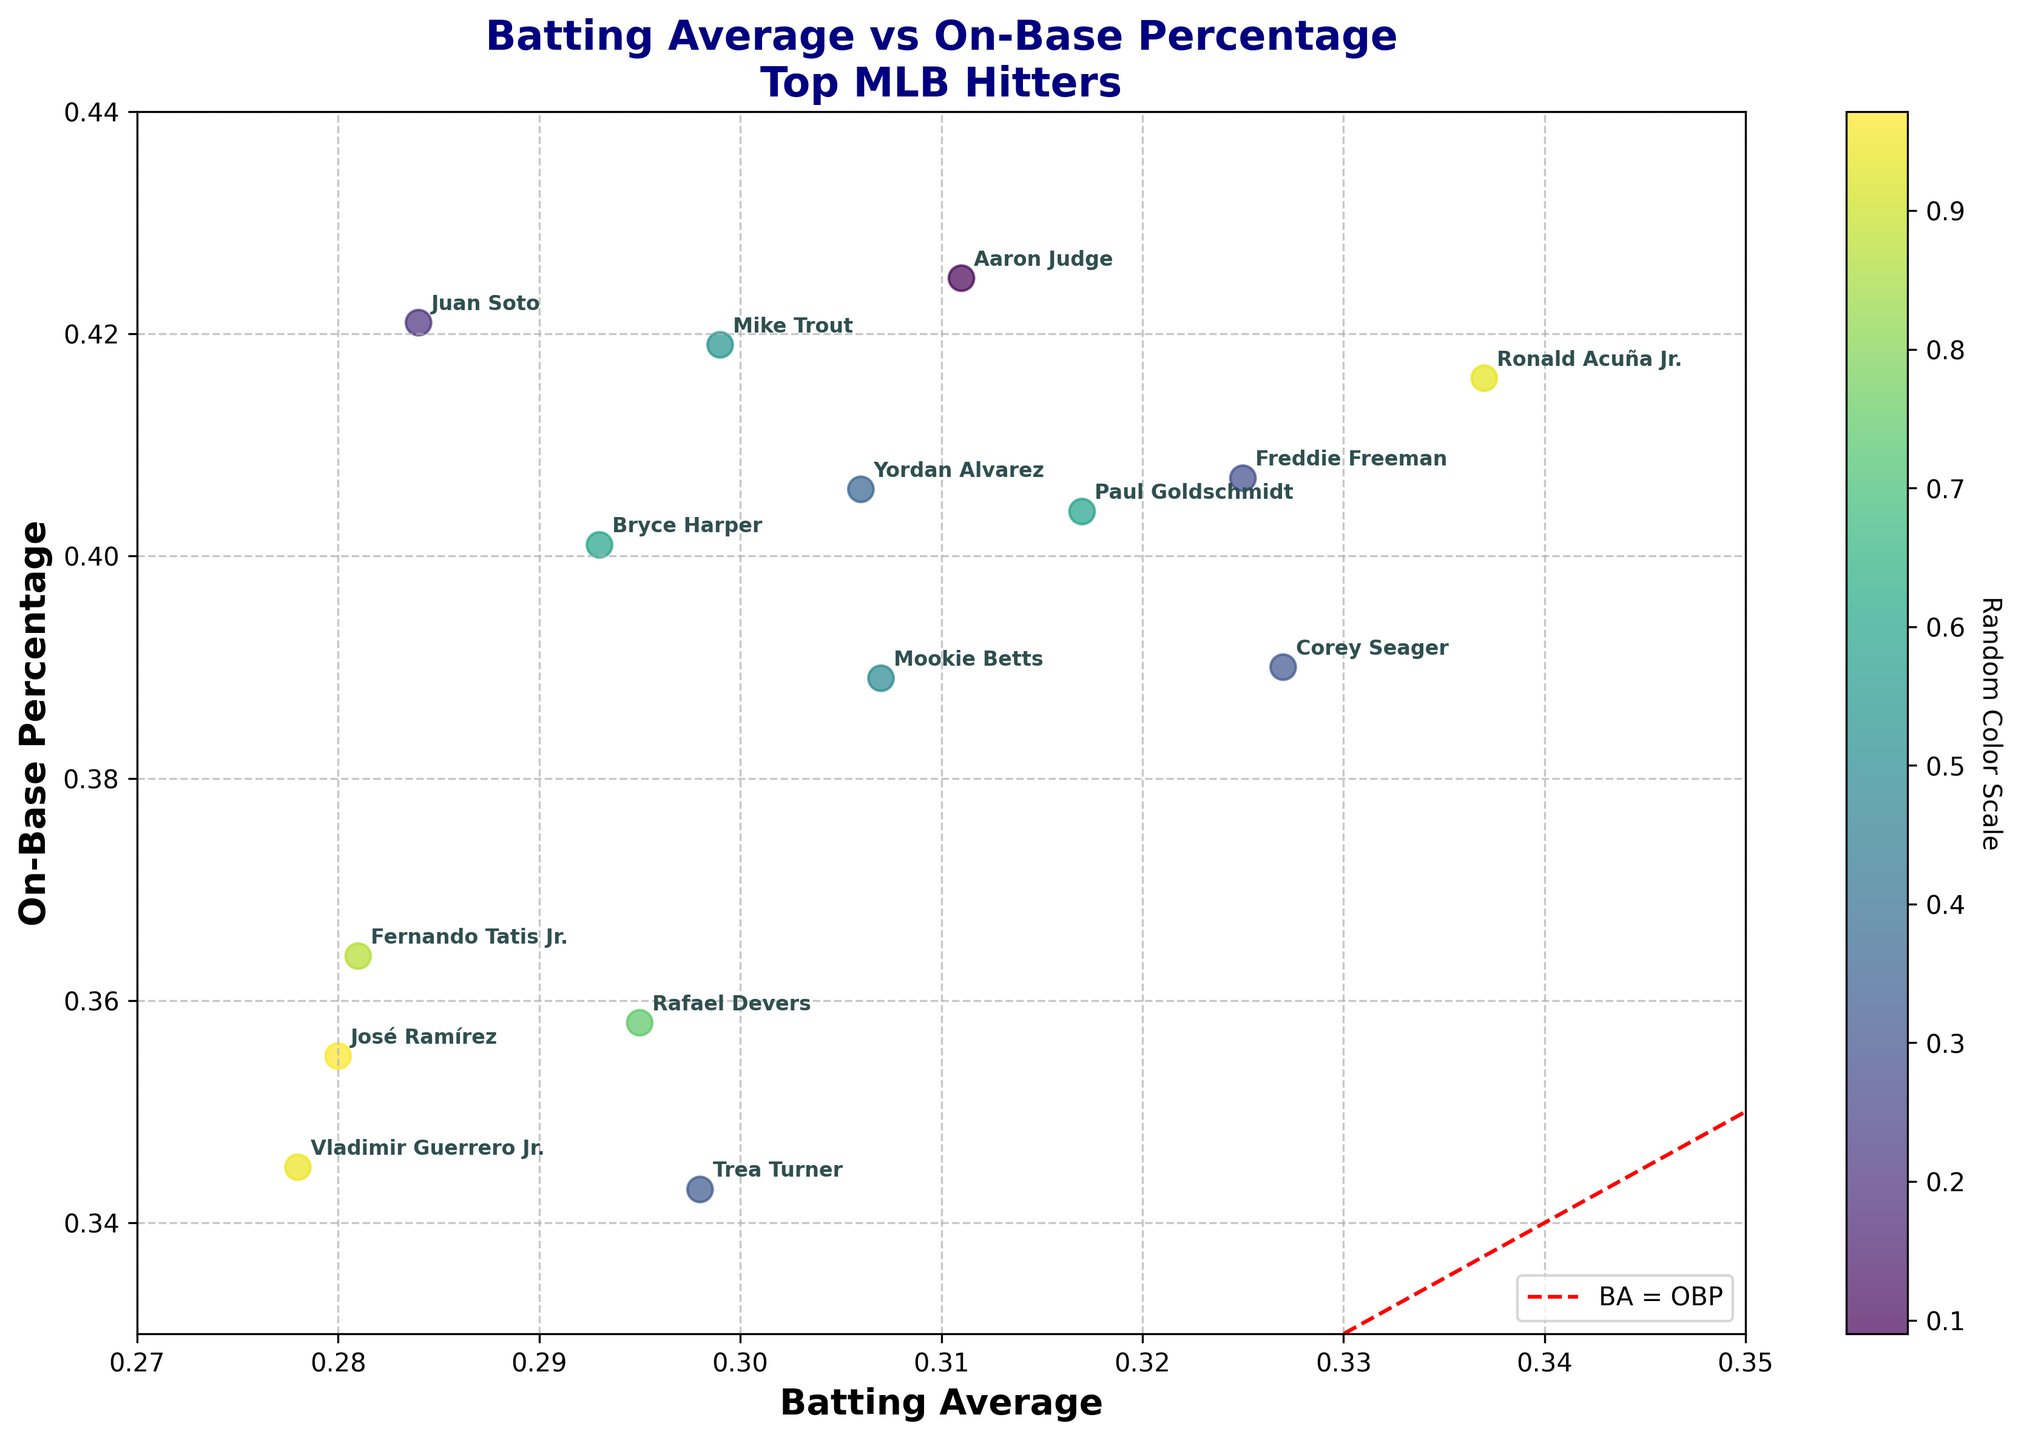How many players have a batting average greater than .300? First, locate the players on the x-axis who have values greater than .300. Count the number of these players. Based on the visual inspection, there are 7 such players.
Answer: 7 Which player has the highest on-base percentage? Examine the y-axis for the highest value, and find the corresponding player label. Aaron Judge has the highest on-base percentage at 0.425.
Answer: Aaron Judge Are there any players with both a batting average and on-base percentage below 0.30 and 0.35, respectively? Check the lower left section of the plot where both the x-values are below 0.30 and y-values are below 0.35. No data points are in this area.
Answer: No Who has a higher on-base percentage, Juan Soto or Bryce Harper? Locate Juan Soto and Bryce Harper on the plot, compare their y-values. Juan Soto (0.421) has a higher on-base percentage than Bryce Harper (0.401).
Answer: Juan Soto Is there a player with a batting average of 0.337? If yes, who is it and what is their on-base percentage? Check for the x-value of 0.337 on the plot, note the corresponding player. Ronald Acuña Jr. has a batting average of 0.337, and his on-base percentage is 0.416.
Answer: Ronald Acuña Jr., 0.416 Which player has the nearest batting average to Corey Seager but a lower on-base percentage? Identify Corey Seager's batting average (0.327) and find nearby x-values. Compare the corresponding y-values (on-base percentages). Paul Goldschmidt has a nearby average (0.317) but slightly lower OBP (0.404 vs. 0.390).
Answer: Paul Goldschmidt Which player is closest to the diagonal line representing BA = OBP? Find the points closest to the red dashed diagonal line. Trea Turner, with a batting average of 0.298 and an on-base percentage of 0.343, is the closest.
Answer: Trea Turner Determine the average on-base percentage of players with a batting average greater than 0.310. Identify the players with x-values greater than 0.310. Then calculate the average y-values for these points: (0.319+0.425+0.416+0.404+0.355)/5 ≈ 0.3998.
Answer: ~0.400 Which player has both the highest batting average and on-base percentage? Compare the x and y values for all points; the player farthest to the top right is Ronald Acuña Jr. (0.337 BA, 0.416 OBP).
Answer: Ronald Acuña Jr 